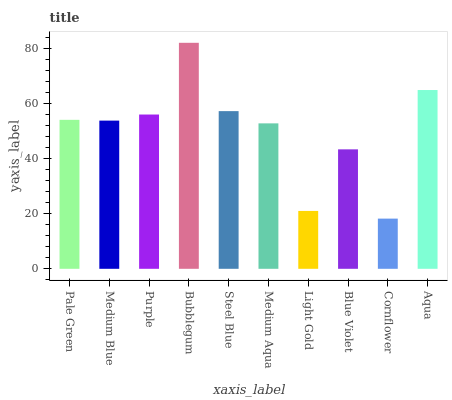Is Cornflower the minimum?
Answer yes or no. Yes. Is Bubblegum the maximum?
Answer yes or no. Yes. Is Medium Blue the minimum?
Answer yes or no. No. Is Medium Blue the maximum?
Answer yes or no. No. Is Pale Green greater than Medium Blue?
Answer yes or no. Yes. Is Medium Blue less than Pale Green?
Answer yes or no. Yes. Is Medium Blue greater than Pale Green?
Answer yes or no. No. Is Pale Green less than Medium Blue?
Answer yes or no. No. Is Pale Green the high median?
Answer yes or no. Yes. Is Medium Blue the low median?
Answer yes or no. Yes. Is Medium Aqua the high median?
Answer yes or no. No. Is Blue Violet the low median?
Answer yes or no. No. 